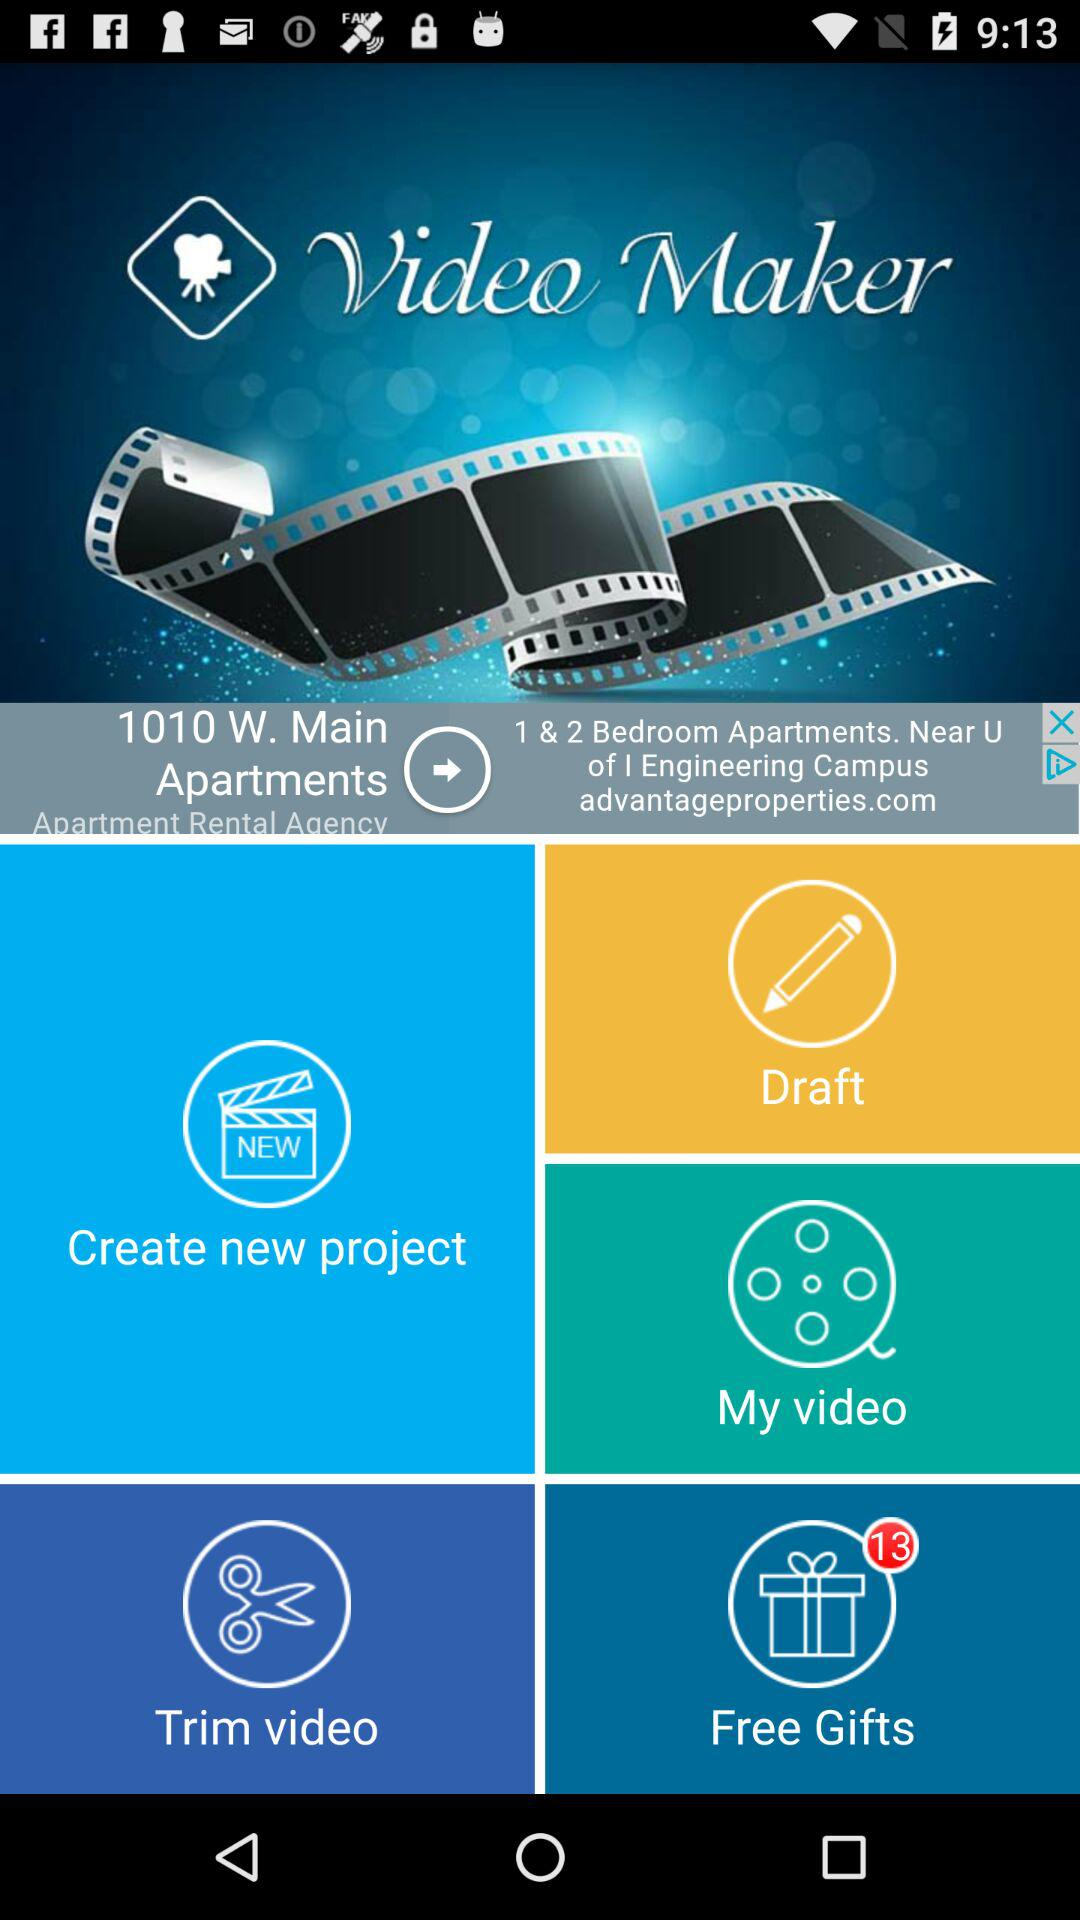How many notifications are there for "Free Gifts"? There are 13 notifications for "Free Gifts". 